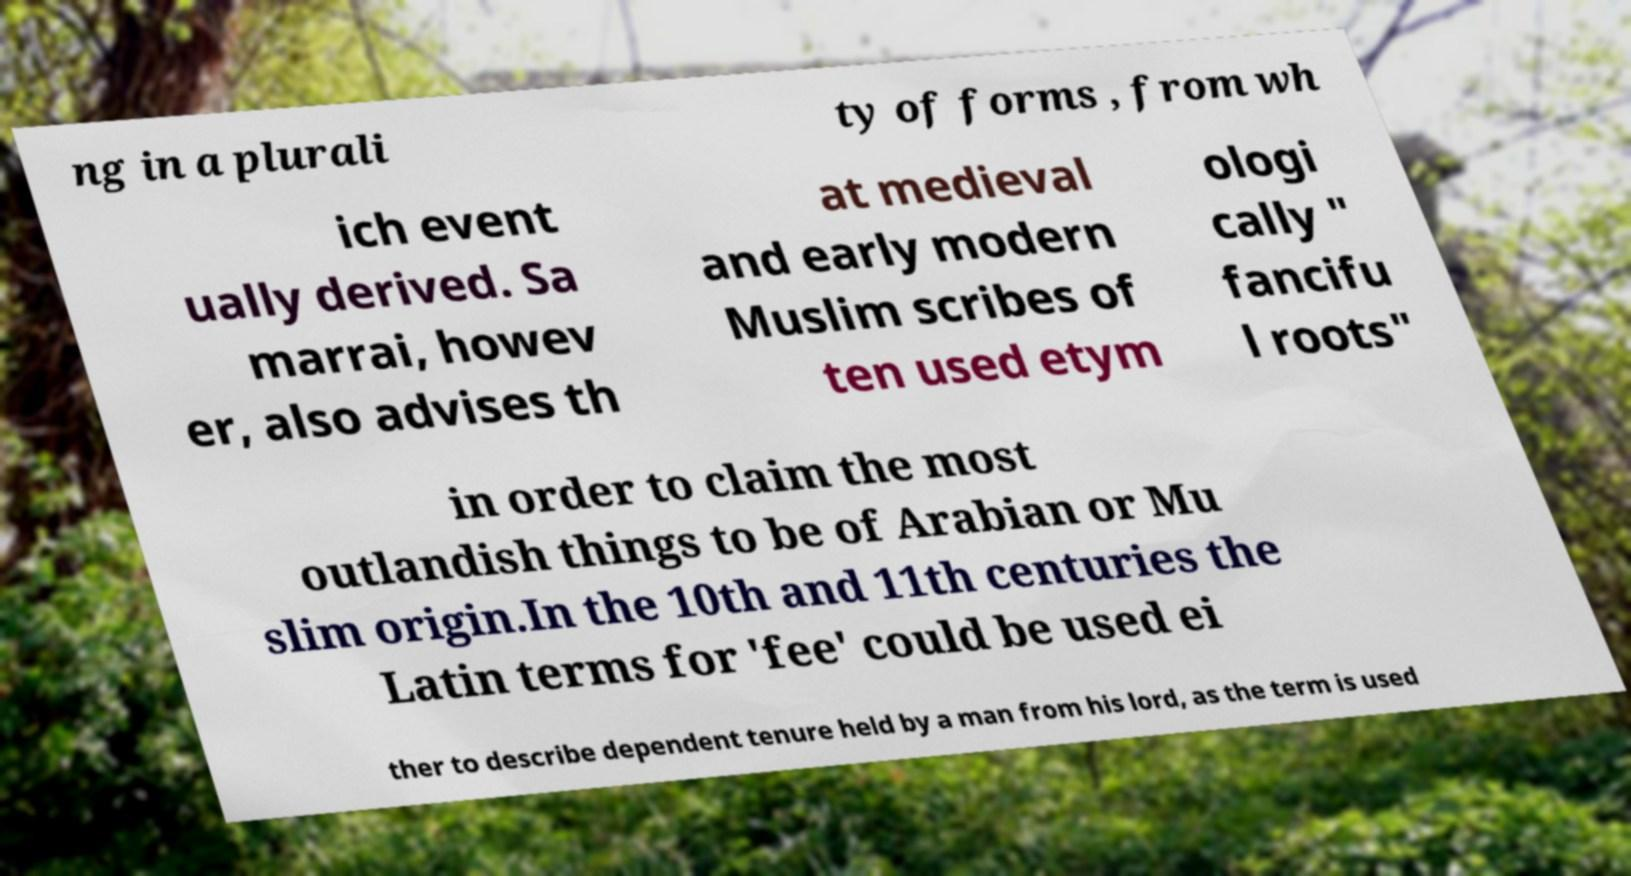There's text embedded in this image that I need extracted. Can you transcribe it verbatim? ng in a plurali ty of forms , from wh ich event ually derived. Sa marrai, howev er, also advises th at medieval and early modern Muslim scribes of ten used etym ologi cally " fancifu l roots" in order to claim the most outlandish things to be of Arabian or Mu slim origin.In the 10th and 11th centuries the Latin terms for 'fee' could be used ei ther to describe dependent tenure held by a man from his lord, as the term is used 